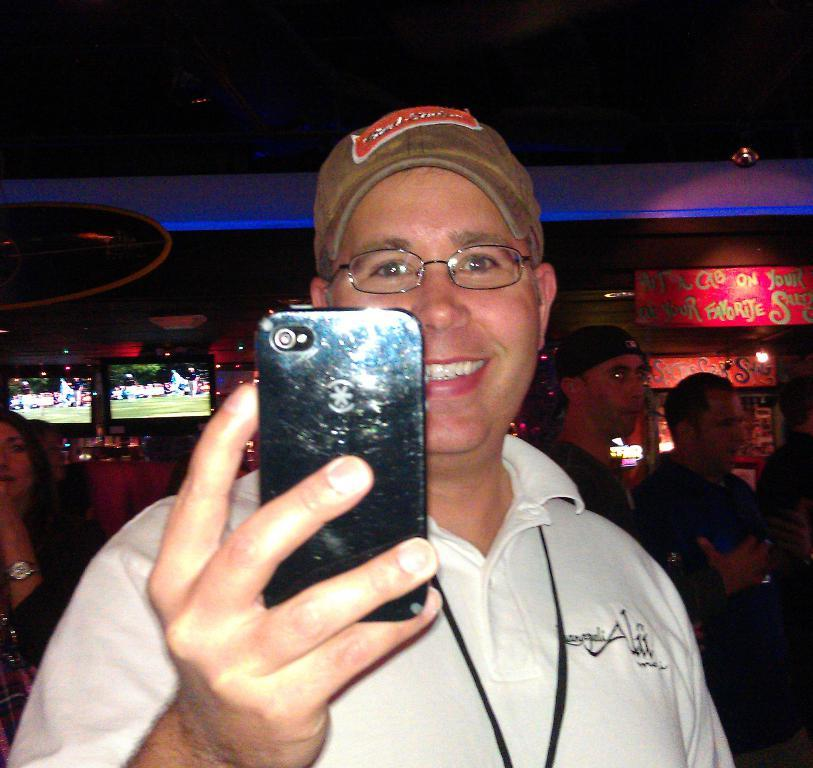How many people are in the image? There is a group of people in the image. Can you describe the arrangement of the people in the image? There is one person in the center of the group. What is the person in the center holding? The person in the center is holding a mobile. What accessories is the person in the center wearing? The person in the center is wearing a spectacle and a cap. What type of page can be seen in the image? There is no page present in the image. Can you describe the cemetery in the image? There is no cemetery present in the image. 